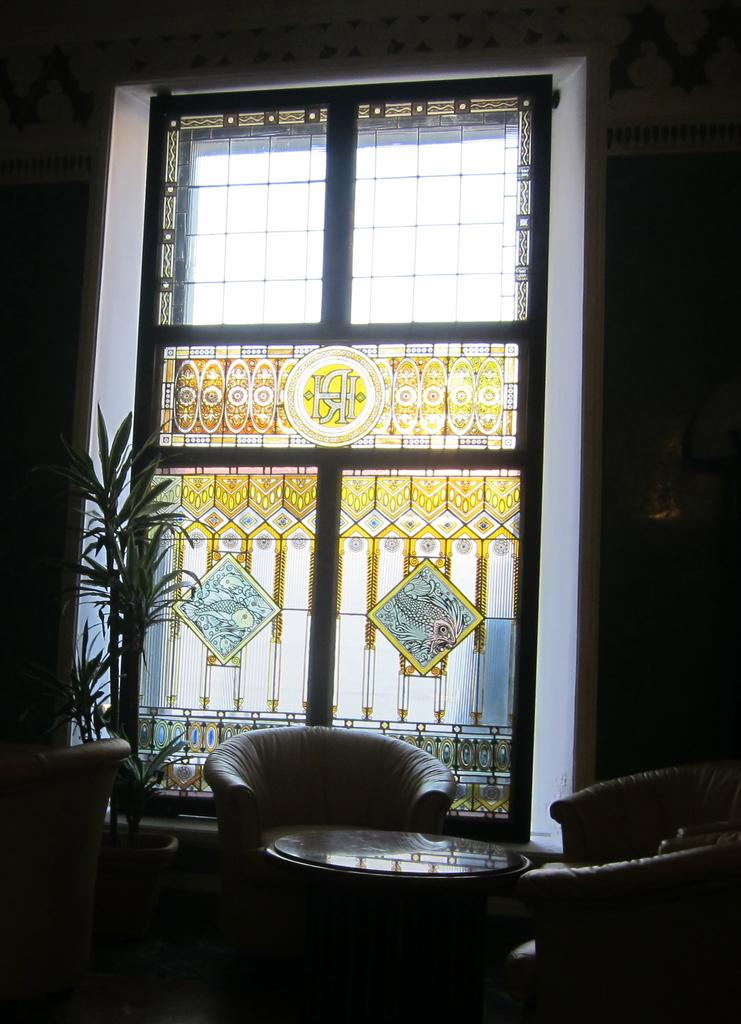What type of opening can be seen in the image? There is a window in the image. What type of living organism is present in the image? There is a plant in the image. What type of furniture is in the image? There is a couch in the image. What type of cake is being served on the side in the image? There is no cake present in the image. What type of container is being used to hold water for the plant in the image? There is no container, such as a pail, visible in the image for holding water for the plant. 